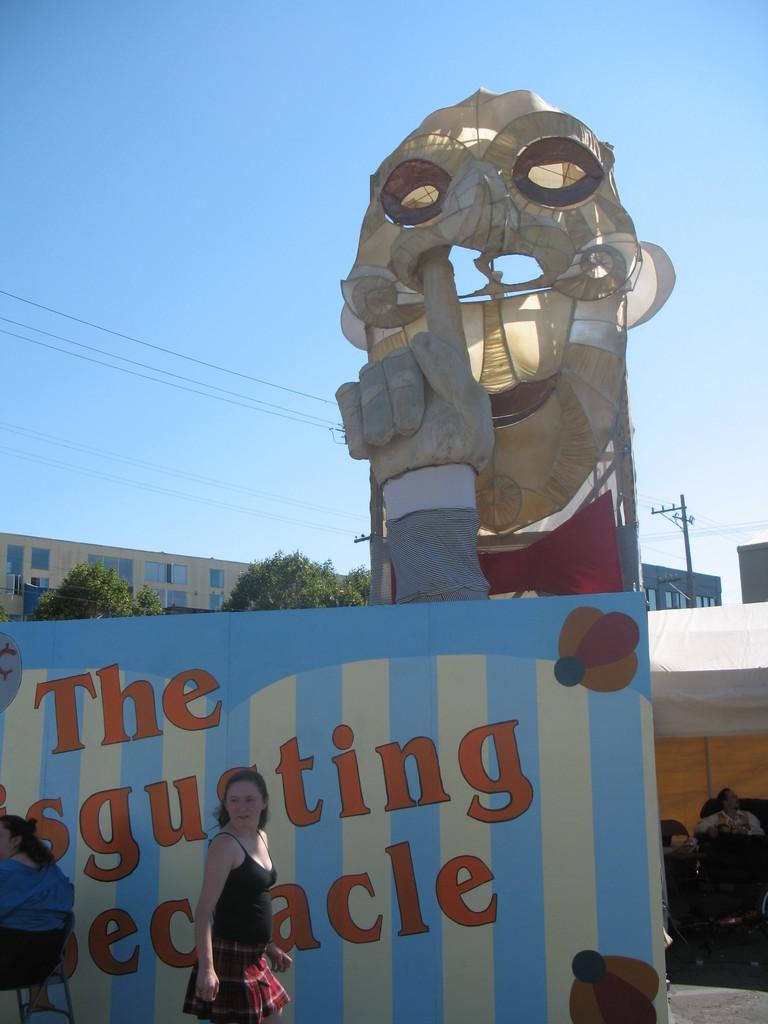What type of objects can be seen in the image? There are boards, people, a tent, poles, trees, buildings, and objects visible in the image. What is the purpose of the boards in the image? The purpose of the boards is not clear from the image, but something is written on one of them. Can you describe the environment in the image? The environment includes trees, buildings, and the sky, which is visible in the image. What structures are present in the image? There is a tent and poles visible in the image. How many people are in the image? There are people present in the image, but the exact number is not specified. What type of polish is being applied to the veil in the image? There is no veil or polish present in the image. What is the value of the item written on the board in the image? The value of the item written on the board cannot be determined from the image, as it does not provide any context or reference for its value. 